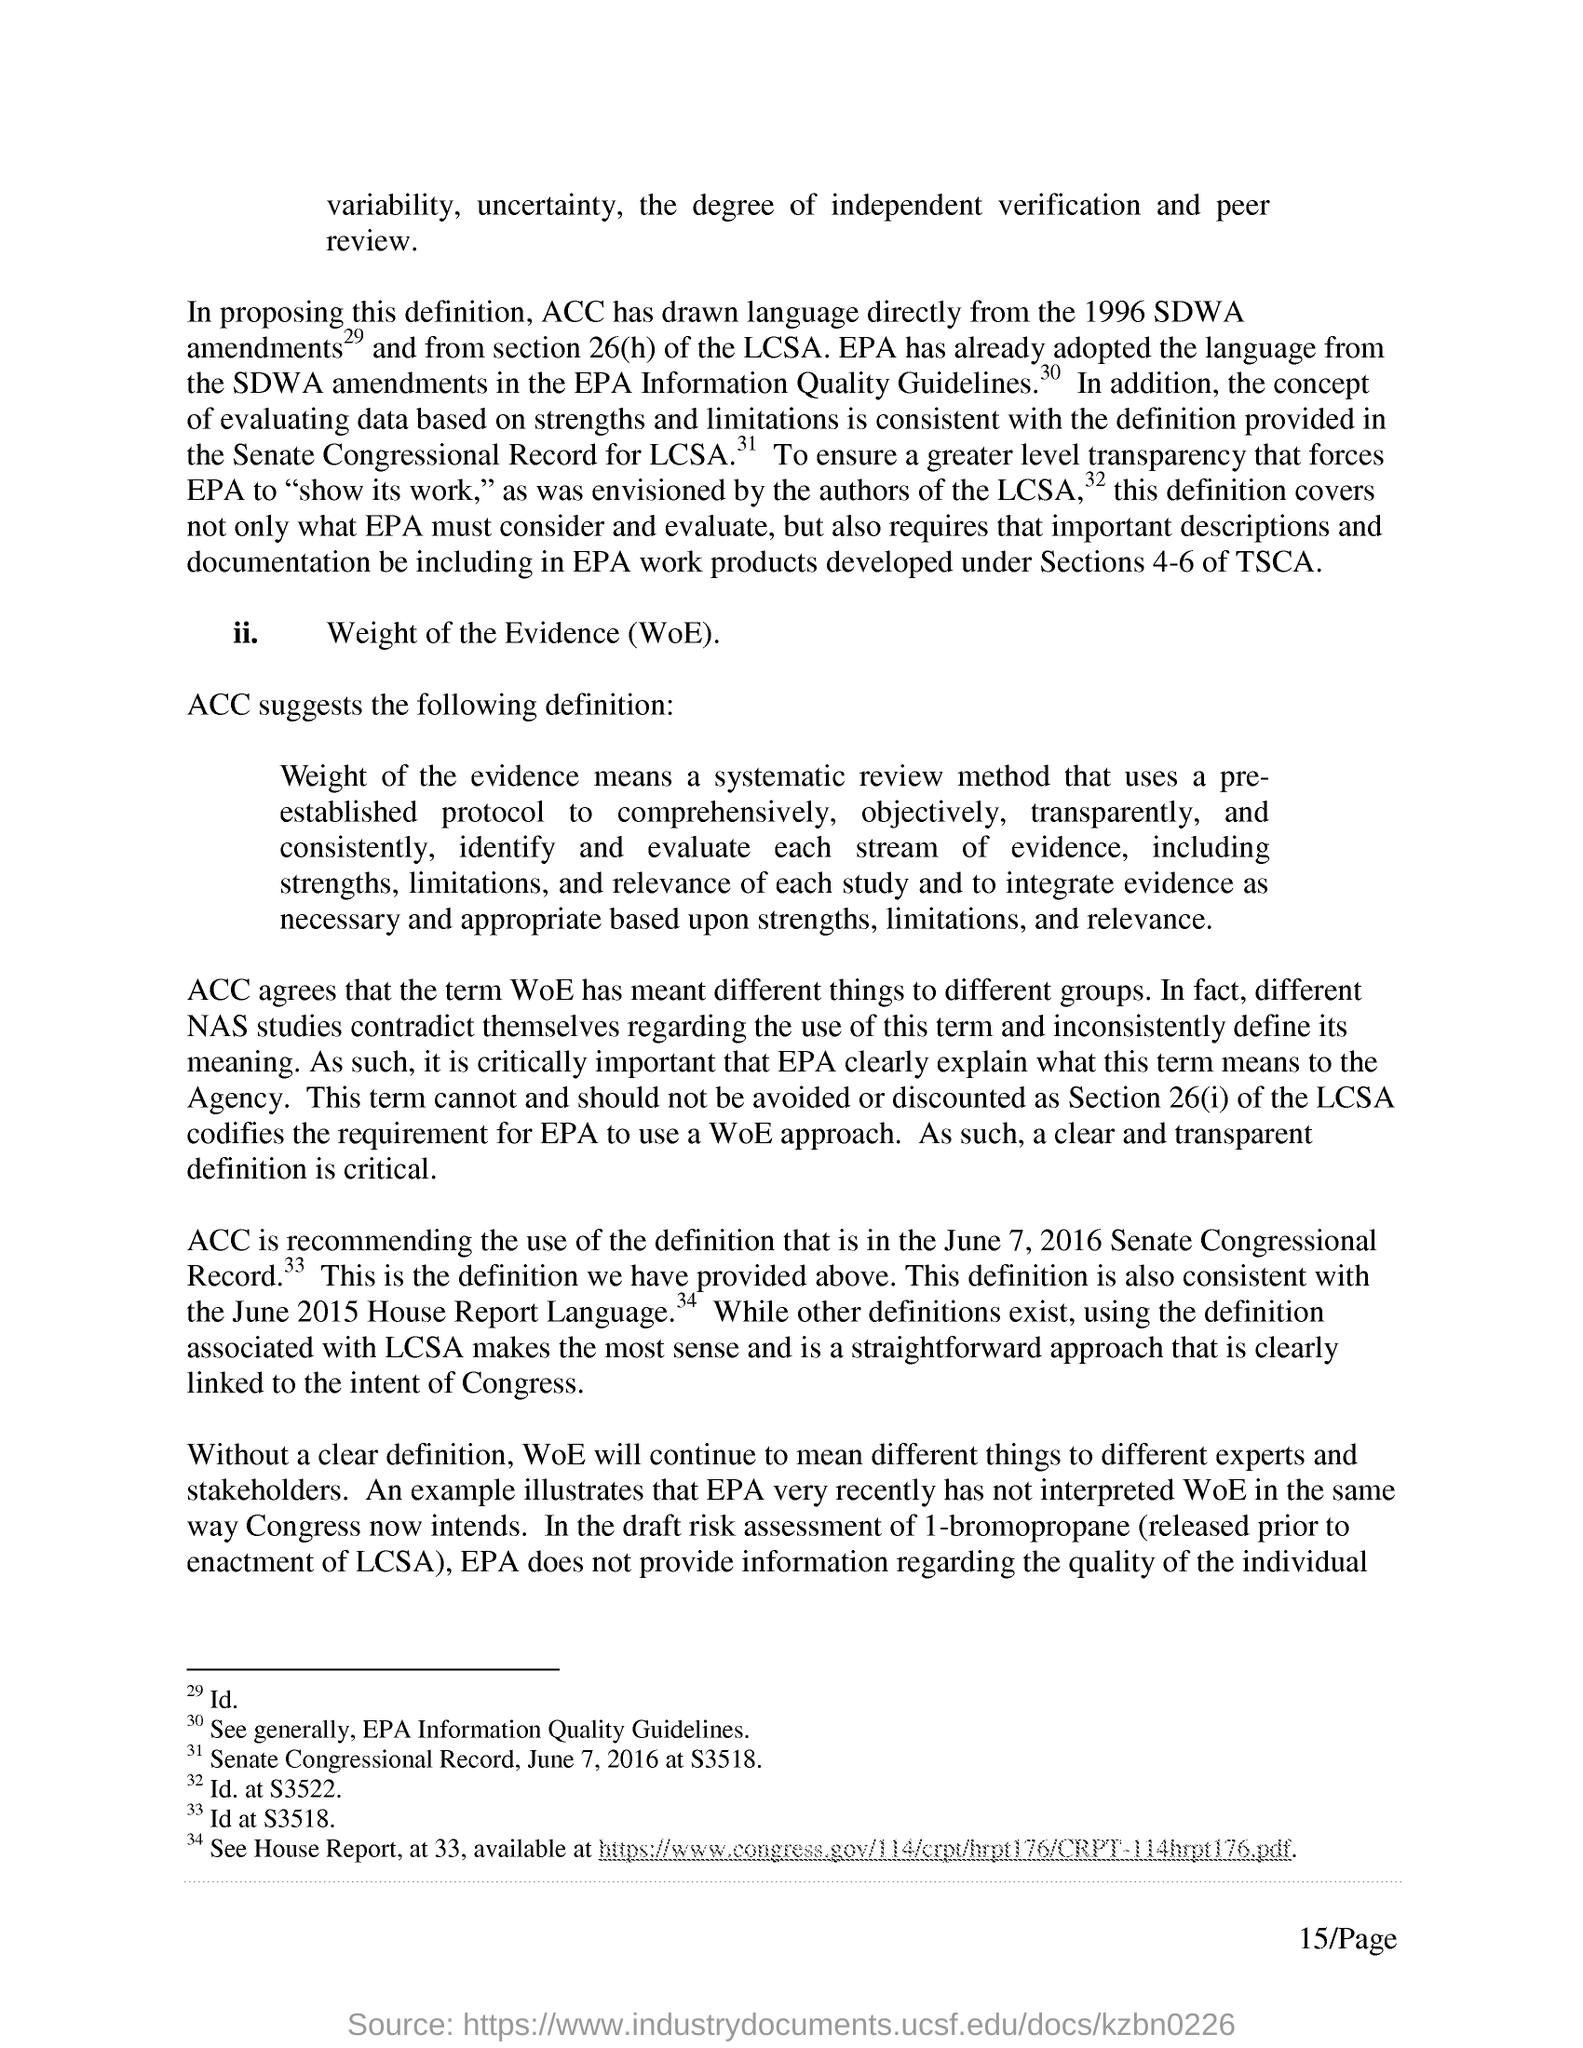What two are the degree of independent verification and peer review?
Provide a short and direct response. Variability, uncertainty. Who agrees that the term WoE has meant different things to different groups?
Offer a very short reply. ACC. Who does not provide information regarding the quality of the individual?
Give a very brief answer. EPA. What is the name of the second point?
Your response must be concise. Weight of the Evidence (WoE). 